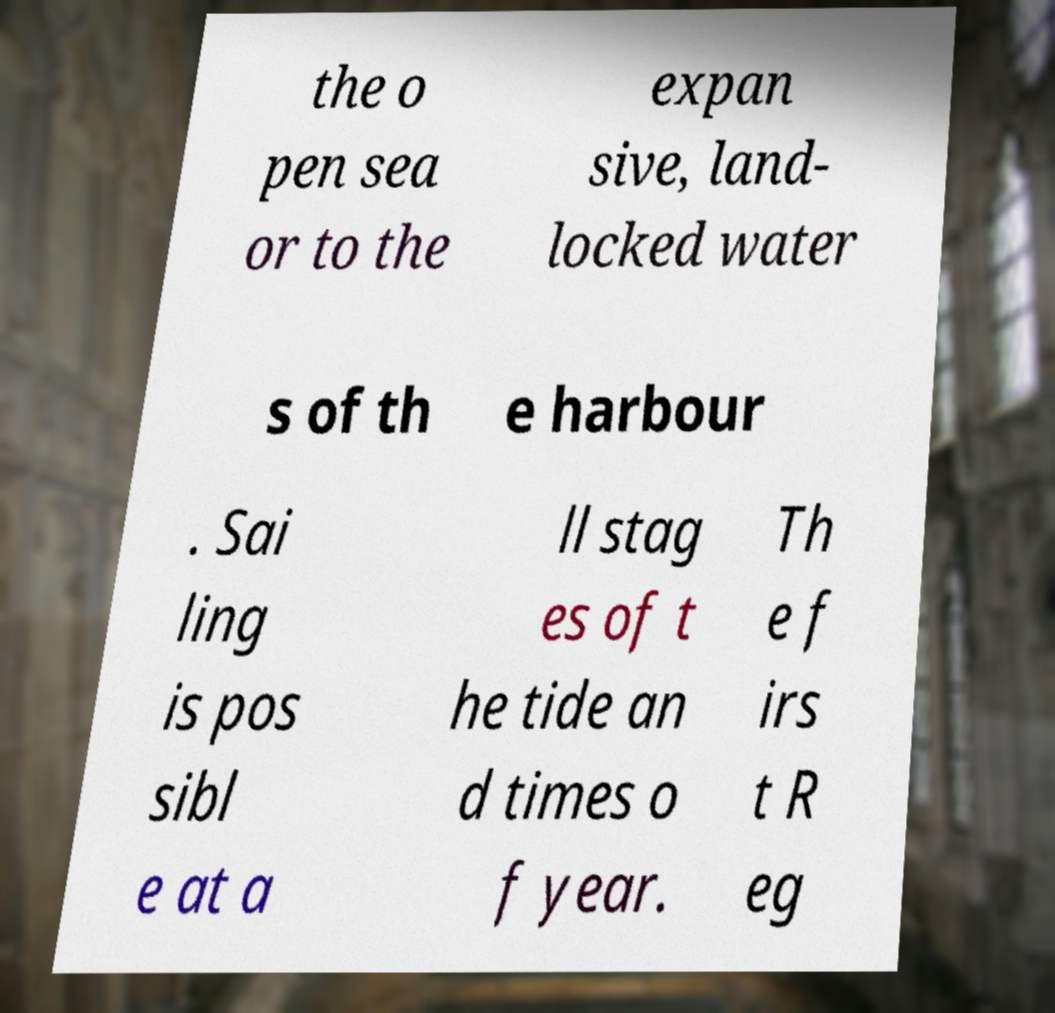There's text embedded in this image that I need extracted. Can you transcribe it verbatim? the o pen sea or to the expan sive, land- locked water s of th e harbour . Sai ling is pos sibl e at a ll stag es of t he tide an d times o f year. Th e f irs t R eg 